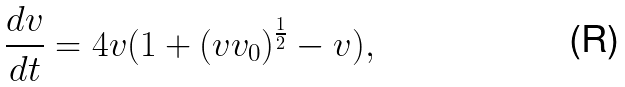Convert formula to latex. <formula><loc_0><loc_0><loc_500><loc_500>\frac { d v } { d t } = 4 v ( 1 + ( v v _ { 0 } ) ^ { \frac { 1 } { 2 } } - v ) ,</formula> 